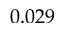Convert formula to latex. <formula><loc_0><loc_0><loc_500><loc_500>0 . 0 2 9</formula> 